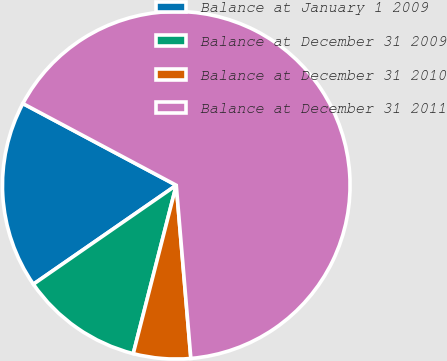<chart> <loc_0><loc_0><loc_500><loc_500><pie_chart><fcel>Balance at January 1 2009<fcel>Balance at December 31 2009<fcel>Balance at December 31 2010<fcel>Balance at December 31 2011<nl><fcel>17.43%<fcel>11.38%<fcel>5.32%<fcel>65.87%<nl></chart> 